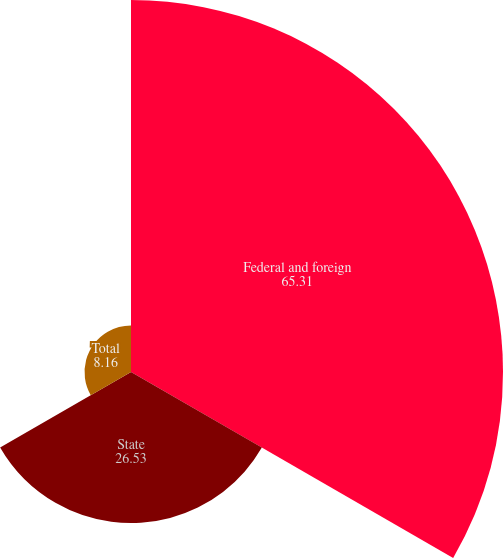Convert chart. <chart><loc_0><loc_0><loc_500><loc_500><pie_chart><fcel>Federal and foreign<fcel>State<fcel>Total<nl><fcel>65.31%<fcel>26.53%<fcel>8.16%<nl></chart> 